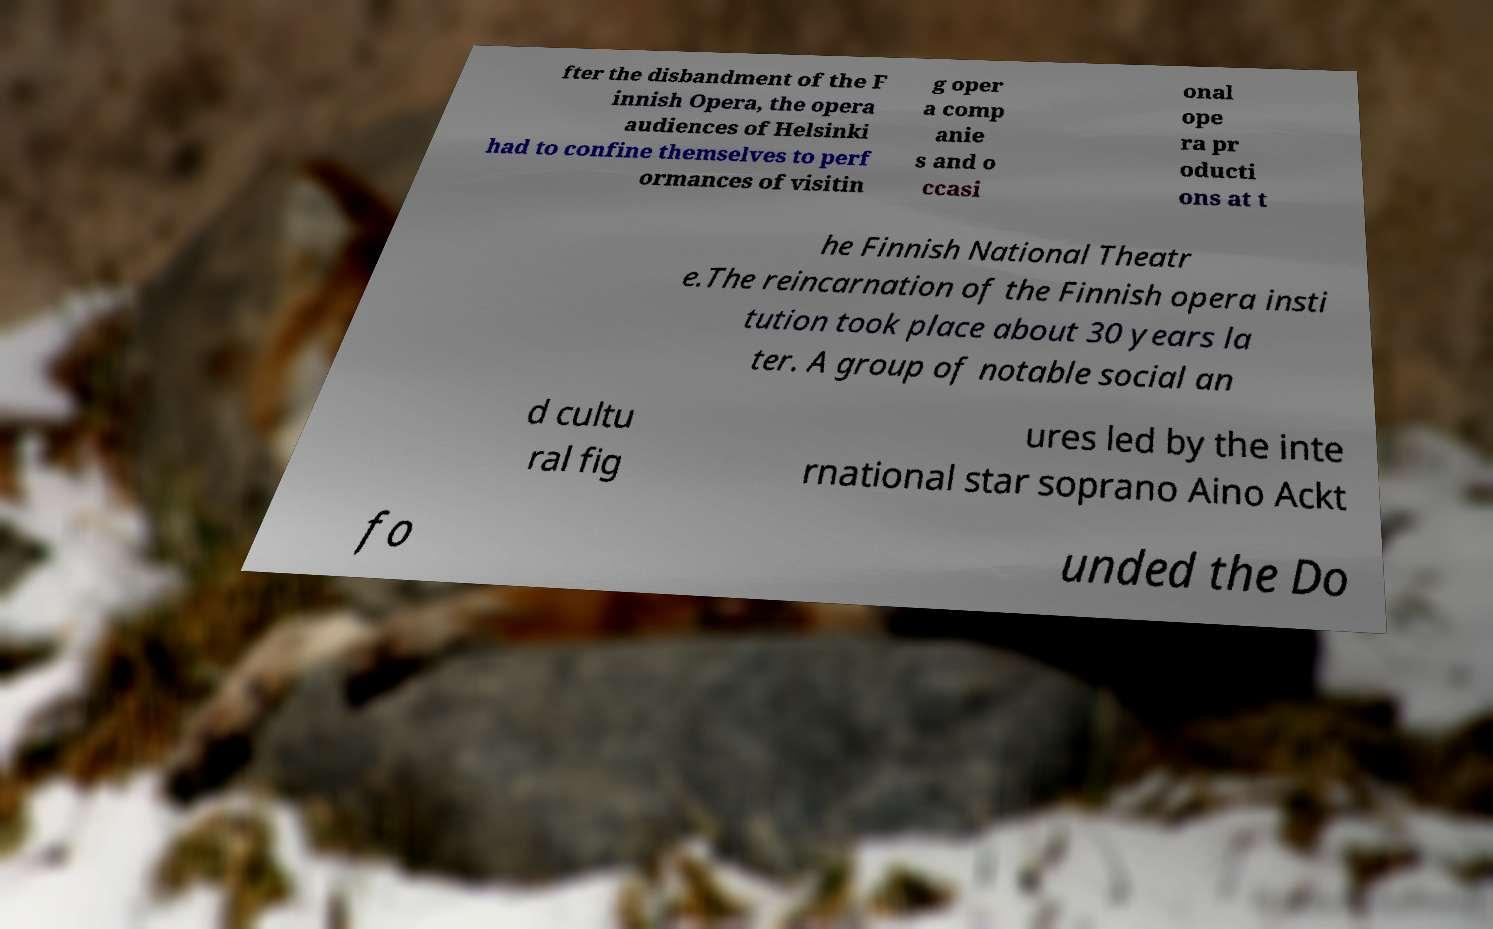What messages or text are displayed in this image? I need them in a readable, typed format. fter the disbandment of the F innish Opera, the opera audiences of Helsinki had to confine themselves to perf ormances of visitin g oper a comp anie s and o ccasi onal ope ra pr oducti ons at t he Finnish National Theatr e.The reincarnation of the Finnish opera insti tution took place about 30 years la ter. A group of notable social an d cultu ral fig ures led by the inte rnational star soprano Aino Ackt fo unded the Do 